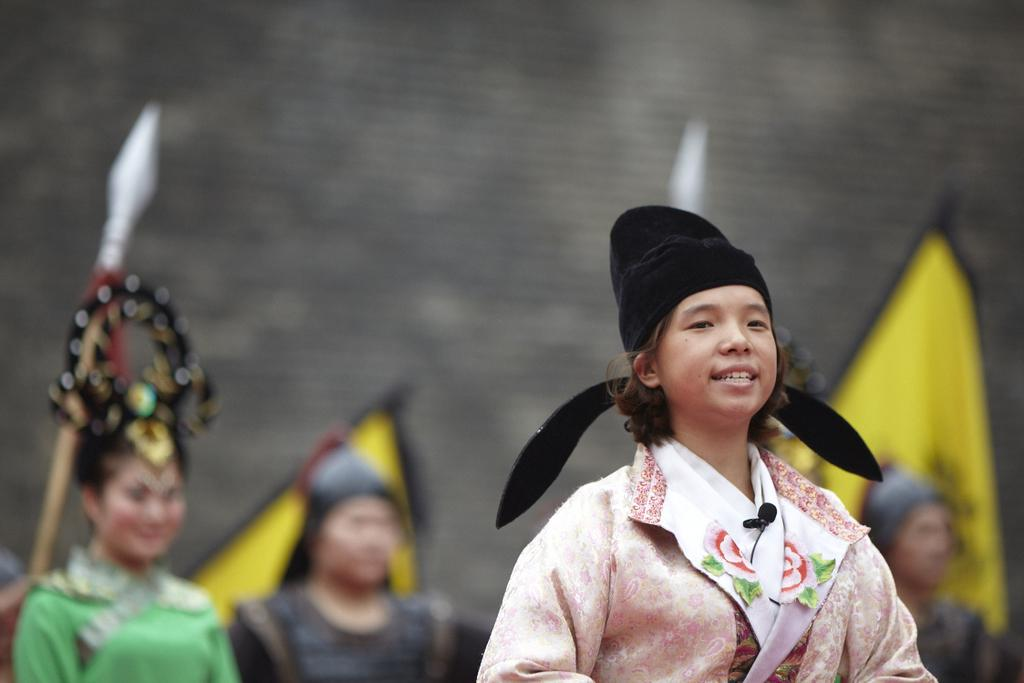How many people are in the image? There are people in the image, but the exact number is not specified. What are the people wearing? The people are wearing traditional dresses. Where are the people standing? The people are standing on the ground. Who are the people looking at? The people are looking at someone, but the identity of that person is not mentioned. What can be seen in the background of the image? In the background of the image, there are flags, weapons, and a wall. What type of flame can be seen on the shirt of one of the people in the image? There is no flame present on any of the people's shirts in the image. What material is the floor made of in the image? The material of the floor is not mentioned in the image. 